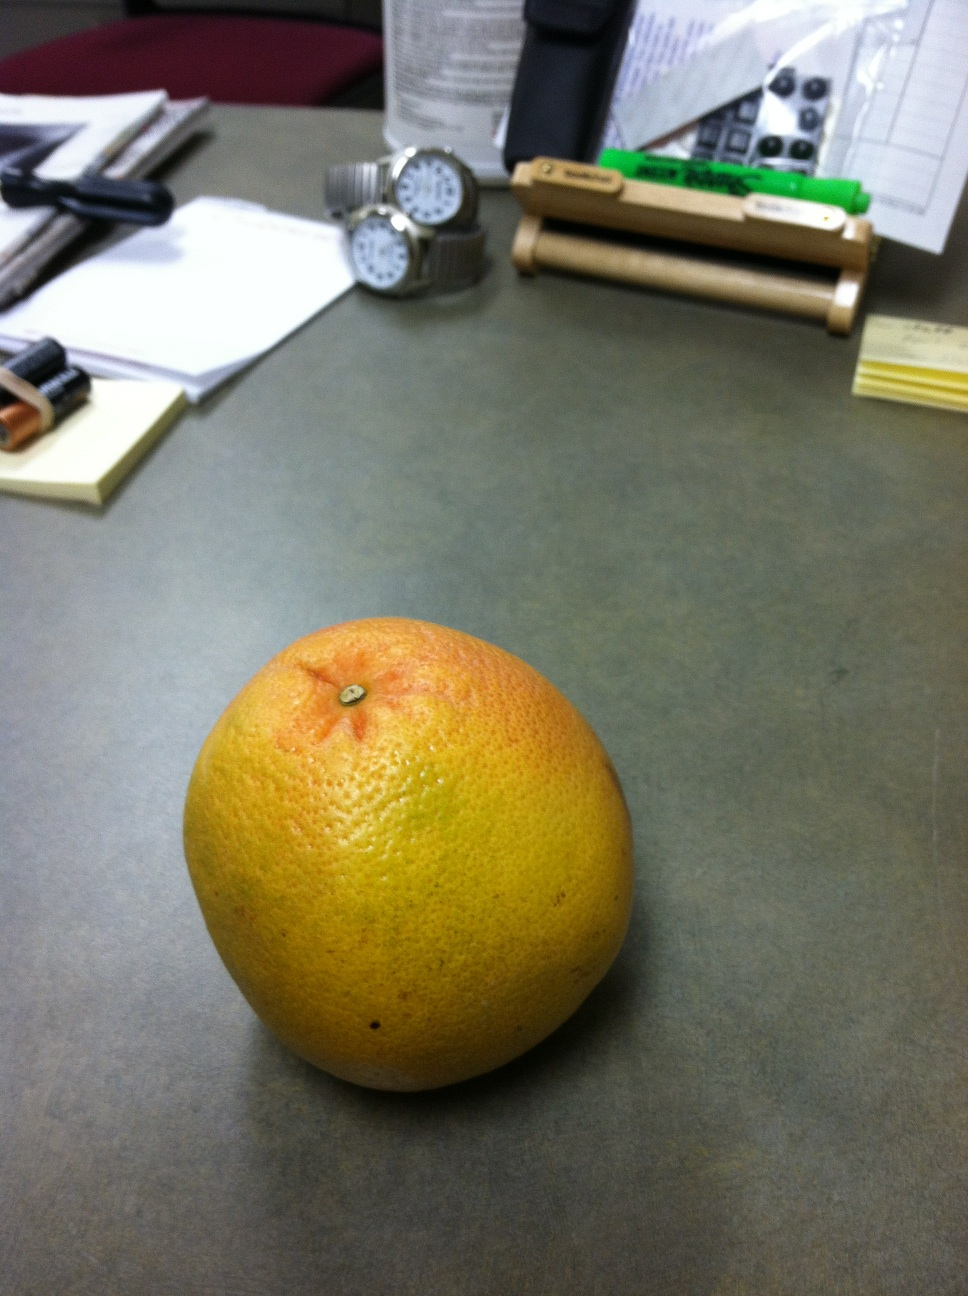What are the health benefits of including this fruit in my diet? This fruit is packed with vitamins, especially vitamin C, which is great for your immune system. It's also high in antioxidants, can provide a boost to digestion due to its fiber content, and can contribute to heart health due to its cholesterol-lowering properties. 